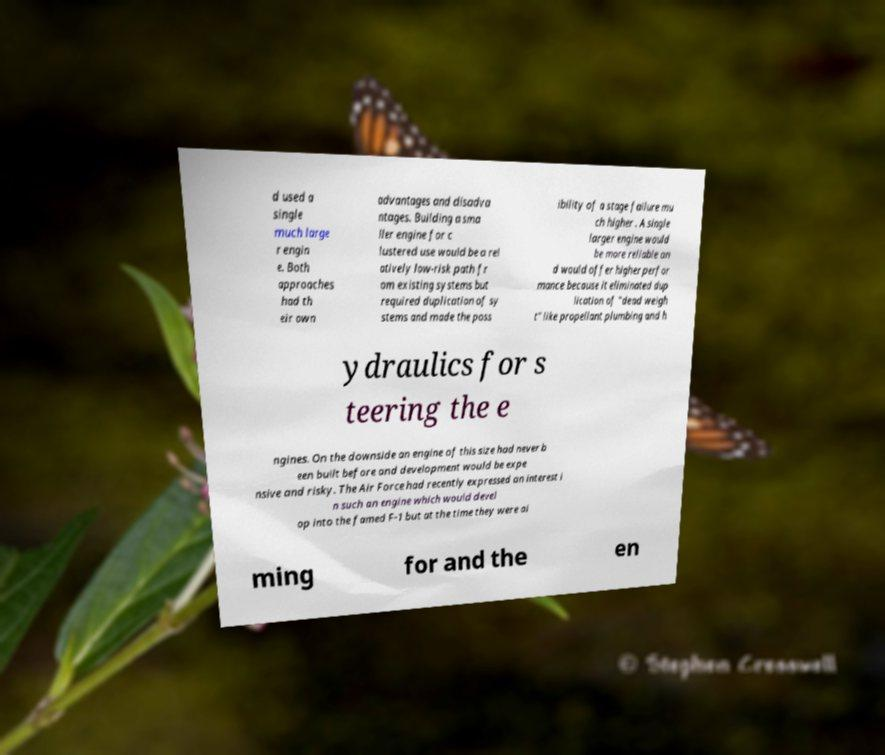Can you accurately transcribe the text from the provided image for me? d used a single much large r engin e. Both approaches had th eir own advantages and disadva ntages. Building a sma ller engine for c lustered use would be a rel atively low-risk path fr om existing systems but required duplication of sy stems and made the poss ibility of a stage failure mu ch higher . A single larger engine would be more reliable an d would offer higher perfor mance because it eliminated dup lication of "dead weigh t" like propellant plumbing and h ydraulics for s teering the e ngines. On the downside an engine of this size had never b een built before and development would be expe nsive and risky. The Air Force had recently expressed an interest i n such an engine which would devel op into the famed F-1 but at the time they were ai ming for and the en 